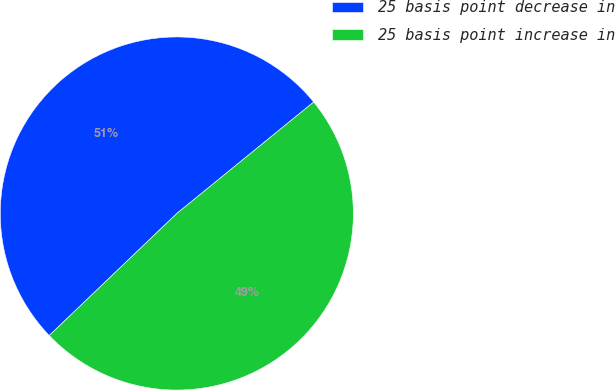<chart> <loc_0><loc_0><loc_500><loc_500><pie_chart><fcel>25 basis point decrease in<fcel>25 basis point increase in<nl><fcel>51.27%<fcel>48.73%<nl></chart> 